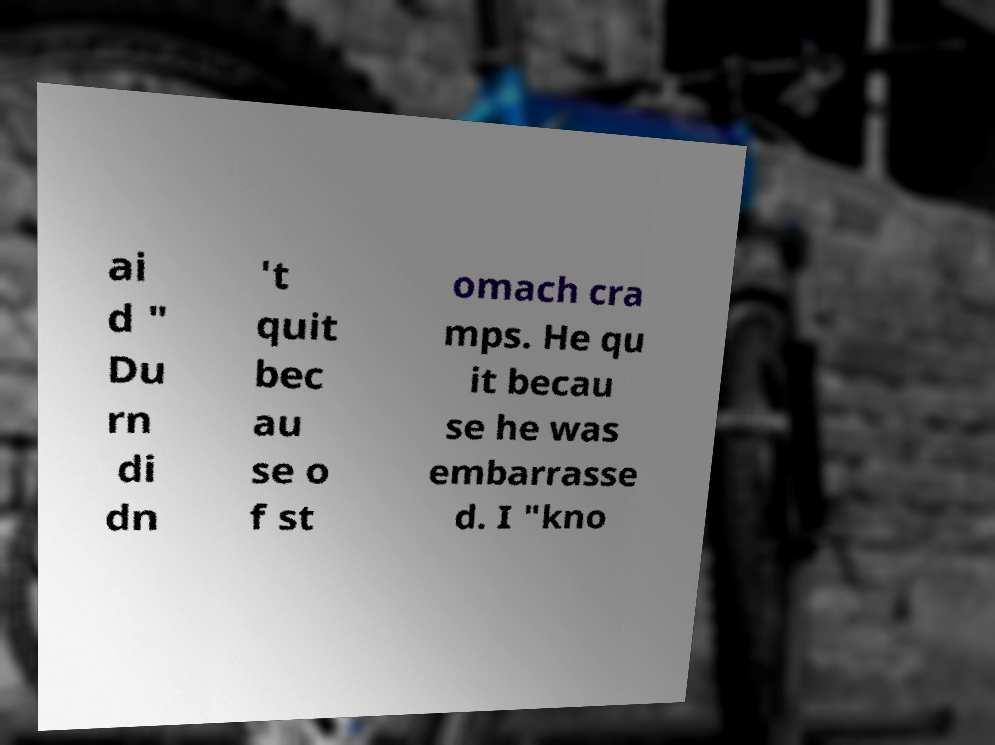Could you assist in decoding the text presented in this image and type it out clearly? ai d " Du rn di dn 't quit bec au se o f st omach cra mps. He qu it becau se he was embarrasse d. I "kno 